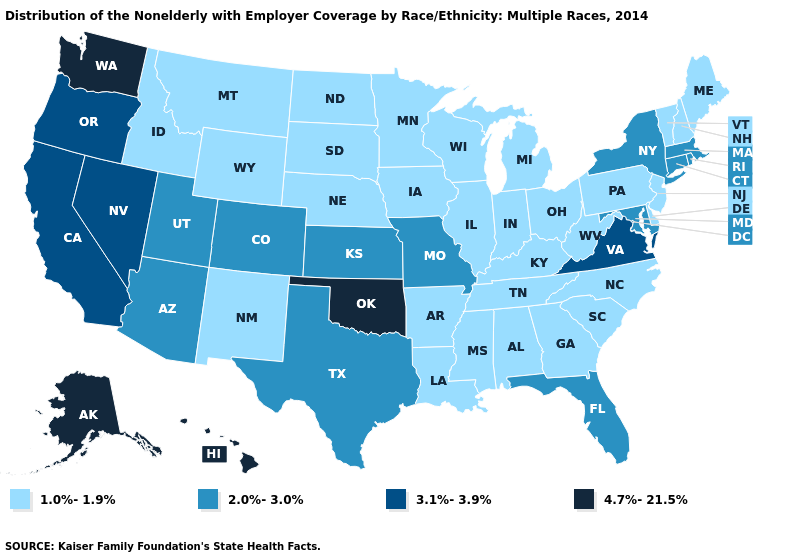Name the states that have a value in the range 4.7%-21.5%?
Write a very short answer. Alaska, Hawaii, Oklahoma, Washington. Which states have the lowest value in the USA?
Concise answer only. Alabama, Arkansas, Delaware, Georgia, Idaho, Illinois, Indiana, Iowa, Kentucky, Louisiana, Maine, Michigan, Minnesota, Mississippi, Montana, Nebraska, New Hampshire, New Jersey, New Mexico, North Carolina, North Dakota, Ohio, Pennsylvania, South Carolina, South Dakota, Tennessee, Vermont, West Virginia, Wisconsin, Wyoming. Does the map have missing data?
Concise answer only. No. Does the first symbol in the legend represent the smallest category?
Give a very brief answer. Yes. Name the states that have a value in the range 2.0%-3.0%?
Write a very short answer. Arizona, Colorado, Connecticut, Florida, Kansas, Maryland, Massachusetts, Missouri, New York, Rhode Island, Texas, Utah. Does Florida have the lowest value in the USA?
Be succinct. No. What is the lowest value in states that border Ohio?
Write a very short answer. 1.0%-1.9%. Among the states that border Illinois , which have the highest value?
Give a very brief answer. Missouri. Name the states that have a value in the range 4.7%-21.5%?
Write a very short answer. Alaska, Hawaii, Oklahoma, Washington. Among the states that border New Mexico , does Oklahoma have the lowest value?
Short answer required. No. What is the highest value in the South ?
Write a very short answer. 4.7%-21.5%. Name the states that have a value in the range 1.0%-1.9%?
Short answer required. Alabama, Arkansas, Delaware, Georgia, Idaho, Illinois, Indiana, Iowa, Kentucky, Louisiana, Maine, Michigan, Minnesota, Mississippi, Montana, Nebraska, New Hampshire, New Jersey, New Mexico, North Carolina, North Dakota, Ohio, Pennsylvania, South Carolina, South Dakota, Tennessee, Vermont, West Virginia, Wisconsin, Wyoming. What is the value of Florida?
Quick response, please. 2.0%-3.0%. What is the lowest value in the Northeast?
Be succinct. 1.0%-1.9%. What is the value of Nebraska?
Concise answer only. 1.0%-1.9%. 